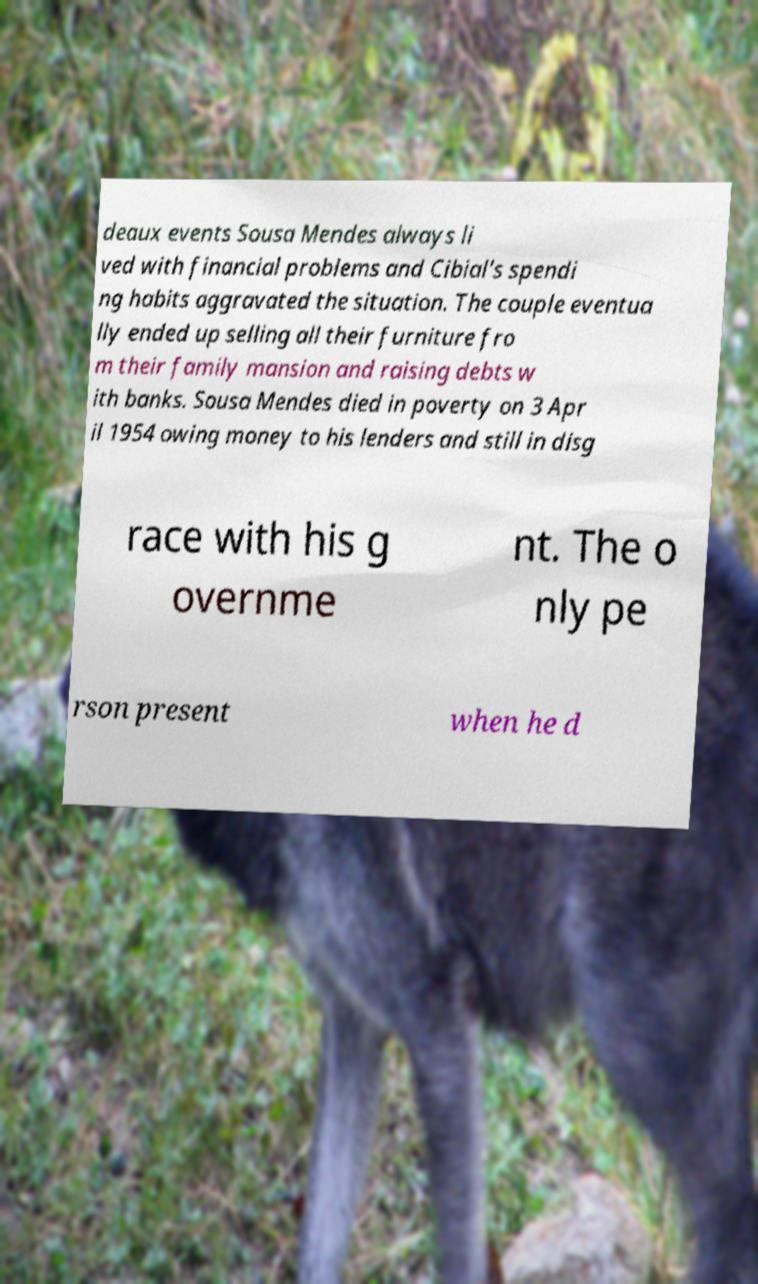What messages or text are displayed in this image? I need them in a readable, typed format. deaux events Sousa Mendes always li ved with financial problems and Cibial's spendi ng habits aggravated the situation. The couple eventua lly ended up selling all their furniture fro m their family mansion and raising debts w ith banks. Sousa Mendes died in poverty on 3 Apr il 1954 owing money to his lenders and still in disg race with his g overnme nt. The o nly pe rson present when he d 